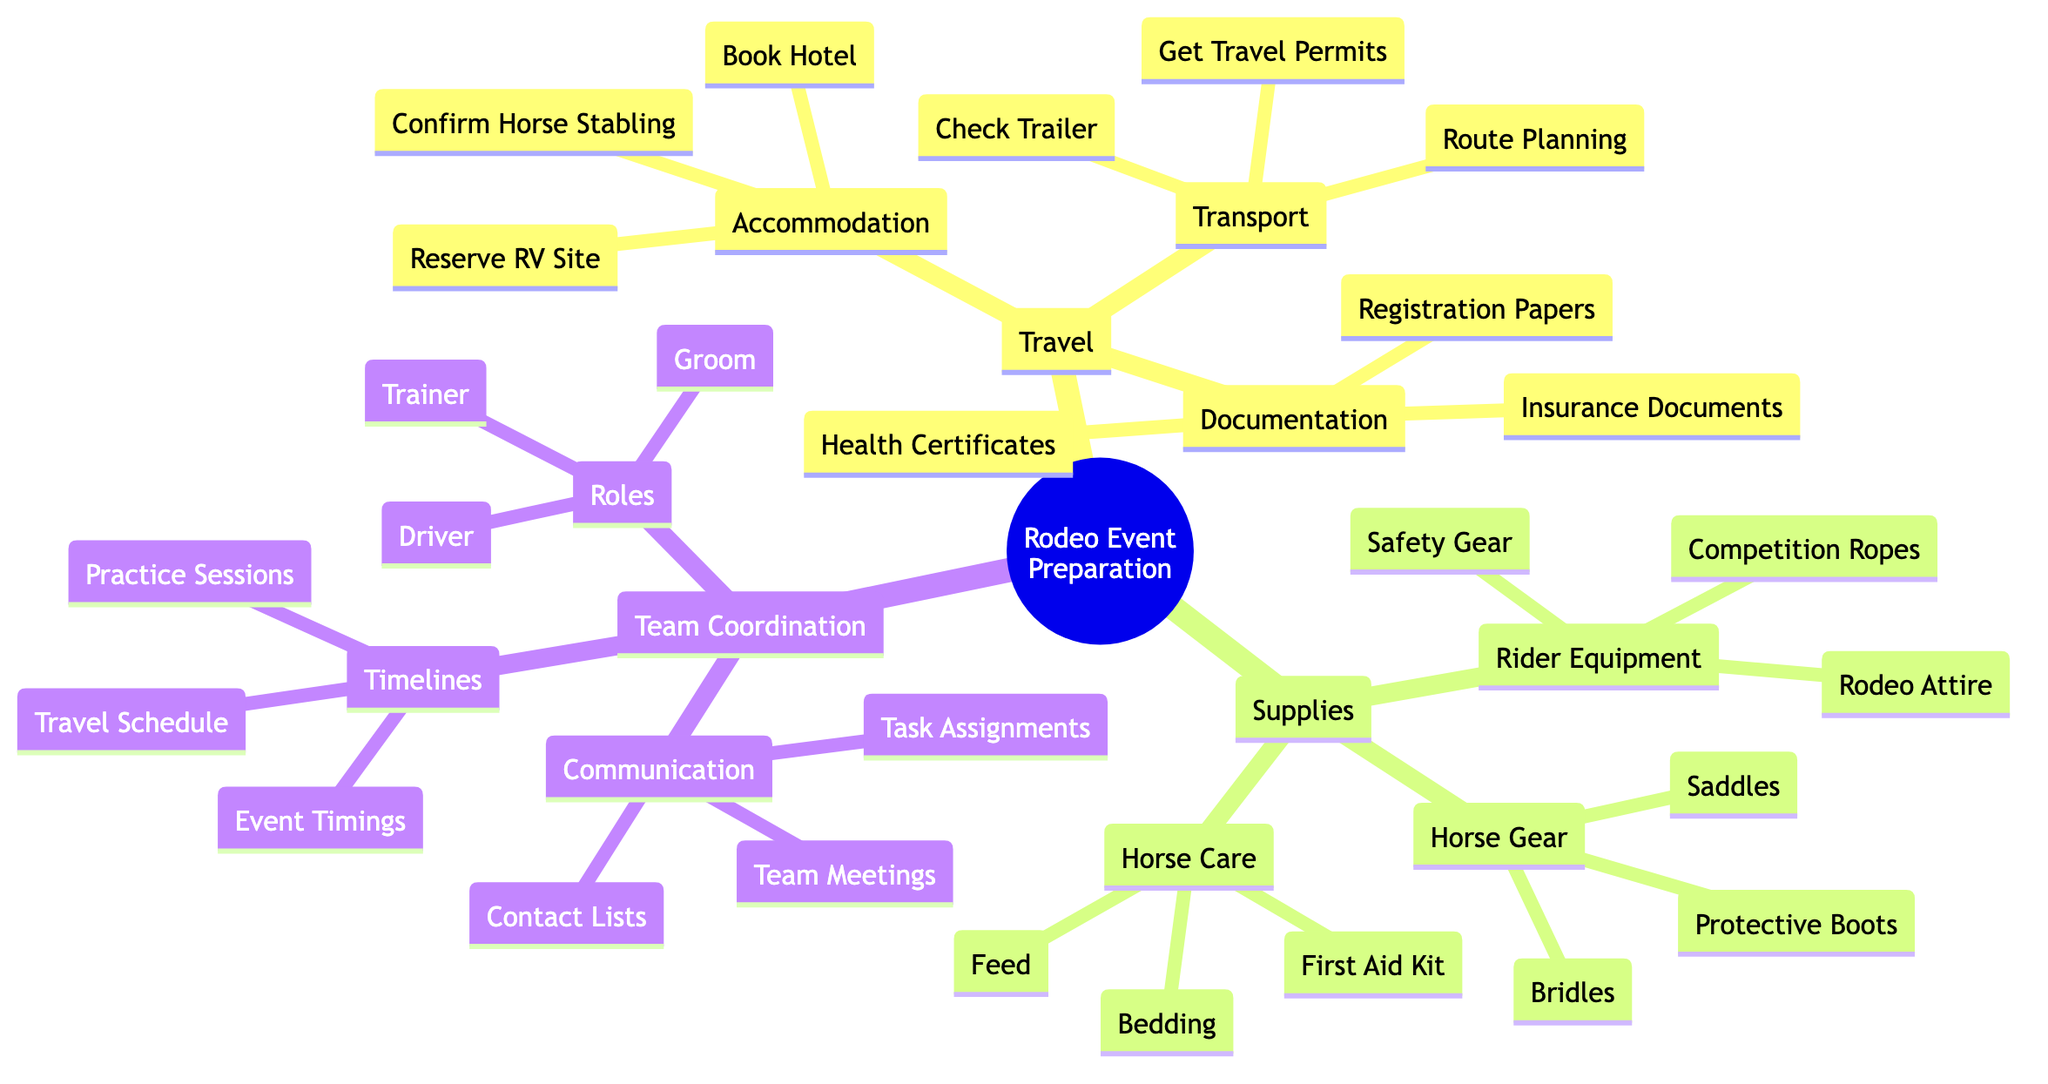What is the first subcategory under Travel? The first subcategory listed under the "Travel" category is "Accommodation," as seen in the structure of the diagram.
Answer: Accommodation How many children does the Supplies category have? The "Supplies" category has three children: "Horse Gear," "Rider Equipment," and "Horse Care," which are all clearly represented in the diagram.
Answer: 3 Which item is listed under Horse Care supplies? The item "First Aid Kit" is listed under the "Horse Care" supplies, as detailed in the supplies breakdown of the diagram.
Answer: First Aid Kit What roles are mentioned under Team Coordination? Under the "Roles" section of "Team Coordination," three roles are mentioned: "Trainer," "Groom," and "Driver," all of which are included in the diagram's details.
Answer: Trainer, Groom, Driver What document is needed for Documentation? The document "Health Certificates" is needed in the "Documentation" category; this is clearly specified in the respective section of the diagram.
Answer: Health Certificates Which category lists "Rodeo Attire"? The category that lists "Rodeo Attire" is "Rider Equipment," as indicated by its placement under the "Supplies" main category in the diagram.
Answer: Rider Equipment How many items are there under Transport? There are three items listed under "Transport": "Check Trailer," "Route Planning," and "Get Travel Permits," as noted in the subcategories under the "Travel" section.
Answer: 3 What is a task mentioned under Team Coordination's Communication? A task mentioned under "Team Coordination" in the "Communication" section is "Team Meetings," which is clearly depicted in the diagram layout.
Answer: Team Meetings What is illustrated in the Timelines section? The "Timelines" section illustrates three items: "Travel Schedule," "Practice Sessions," and "Event Timings," which can be observed in the structured outline.
Answer: Travel Schedule, Practice Sessions, Event Timings 